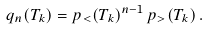Convert formula to latex. <formula><loc_0><loc_0><loc_500><loc_500>q _ { n } ( T _ { k } ) = p _ { < } ( T _ { k } ) ^ { n - 1 } \, p _ { > } ( T _ { k } ) \, .</formula> 